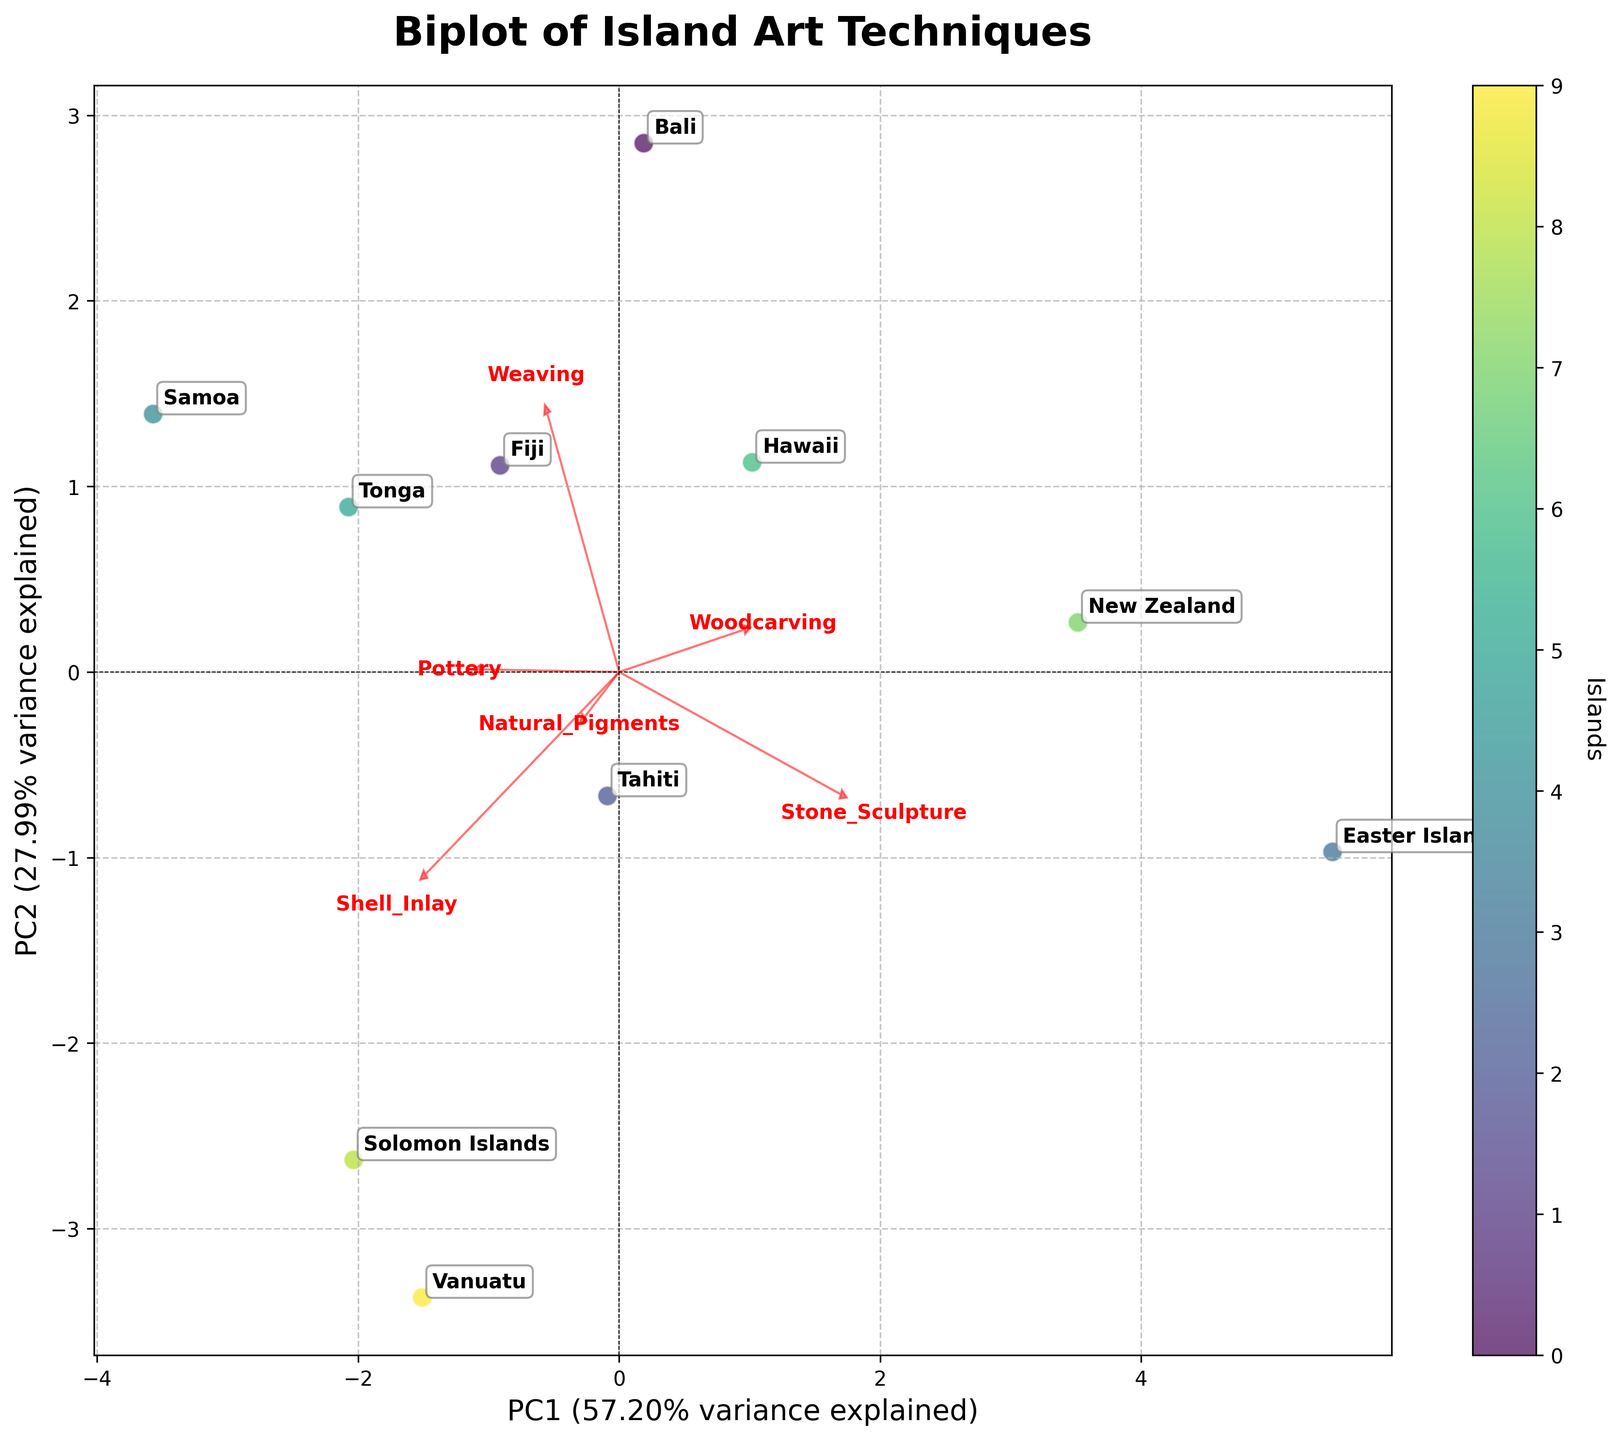What is the title of the biplot? The title of the biplot is mentioned at the top of the plot. It is "Biplot of Island Art Techniques".
Answer: Biplot of Island Art Techniques Which island is associated with the highest value in woodcarving? To find the island with the highest value in woodcarving, look for the island label that aligns with the highest value on the plotting dimension related to woodcarving. In the dataset, Easter Island has a value of 9 for woodcarving and should be near the end of the load vector for woodcarving.
Answer: Easter Island How many islands are represented in the biplot? Each island is represented by a labeled point in the scatter plot. By counting these labeled points, we can determine the number of islands. There are ten points with labels.
Answer: 10 Which artistic technique contributes most to PC1, and how can you tell? The direction and length of the loadings vectors indicate the contribution of each artistic technique to the principal components. By looking at the longest vector pointed in the direction of the x-axis (representing PC1), we can determine that 'Weaving' has the highest contribution to PC1 since its arrow is longest in the x direction.
Answer: Weaving Are there any islands that overlap or are very close to each other on the biplot? If so, which ones? To identify overlapped or closely situated islands, look for points that are clustered together or nearly overlap. 'Fiji' and 'Tonga' are examples of islands that appear very close to each other on the plot.
Answer: Fiji and Tonga Are natural pigments more influential in PC1 or PC2? The influence of natural pigments on PC1 or PC2 depends on the orientation and length of its loading vector. If the arrow for 'Natural Pigments' points more towards the x-axis, it influences PC1 more; if it's more towards the y-axis, it influences PC2 more. The arrow for 'Natural Pigments' tilts more towards PC2, suggesting it has a greater influence on PC2.
Answer: PC2 Which artistic technique is least represented by the principal components? To determine the least represented technique, identify the arrow with the shortest length, as it indicates the smallest loading. 'Shell Inlay' has the shortest arrow, suggesting it is least represented by the principal components.
Answer: Shell Inlay Compare the positions of ‘Hawaii’ and ‘Samoa’ on the biplot. Which techniques seem to separate them the most? Examine the relative positions of 'Hawaii' and 'Samoa' and consider the directions of the loading vectors separating them most distinctly. 'Shell Inlay' and 'Stone Sculpture' vectors seem to play a significant role in differentiating these two islands based on their projections.
Answer: Shell Inlay and Stone Sculpture Which island aligns most closely with the vector for stone sculpture? To identify the island most closely aligning with the vector for stone sculpture, look for the island point nearest to the direction of the stone sculpture load vector. 'Easter Island' aligns closely with the vector for stone sculpture.
Answer: Easter Island What percentage of total variance is explained by the first principal component (PC1)? The percentage of total variance explained by PC1 can be found in the x-axis label, which includes this information. According to the label, PC1 explains 37.50% of the variance.
Answer: 37.50% 